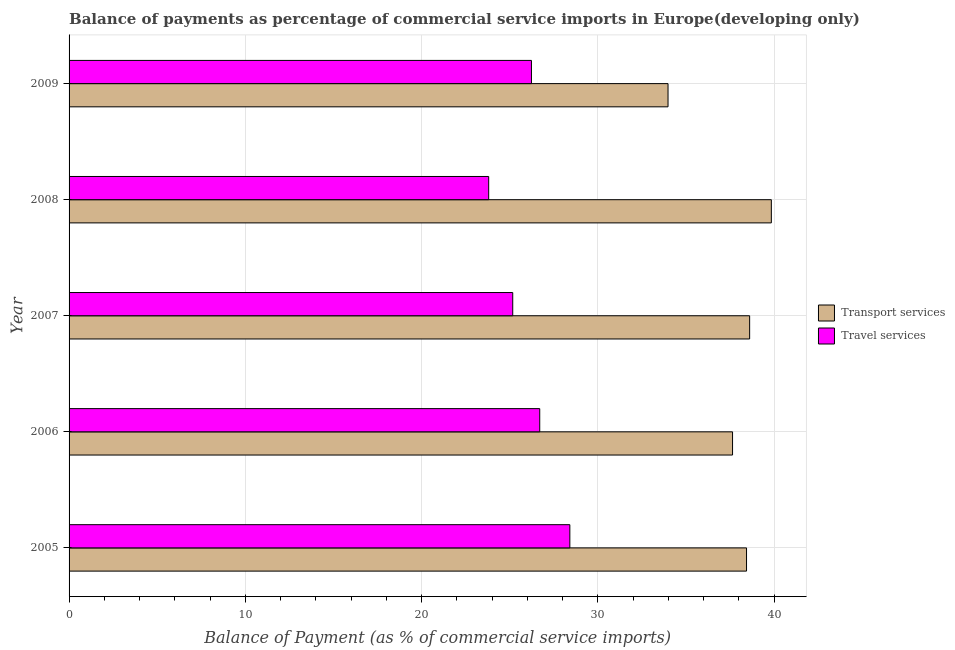What is the label of the 5th group of bars from the top?
Make the answer very short. 2005. What is the balance of payments of travel services in 2008?
Provide a succinct answer. 23.81. Across all years, what is the maximum balance of payments of travel services?
Provide a short and direct response. 28.42. Across all years, what is the minimum balance of payments of transport services?
Provide a succinct answer. 33.99. In which year was the balance of payments of travel services minimum?
Keep it short and to the point. 2008. What is the total balance of payments of transport services in the graph?
Your response must be concise. 188.54. What is the difference between the balance of payments of travel services in 2006 and that in 2007?
Your response must be concise. 1.53. What is the difference between the balance of payments of travel services in 2008 and the balance of payments of transport services in 2007?
Offer a terse response. -14.81. What is the average balance of payments of travel services per year?
Your answer should be compact. 26.07. In the year 2006, what is the difference between the balance of payments of travel services and balance of payments of transport services?
Keep it short and to the point. -10.94. In how many years, is the balance of payments of transport services greater than 2 %?
Keep it short and to the point. 5. What is the ratio of the balance of payments of travel services in 2006 to that in 2007?
Your answer should be very brief. 1.06. Is the balance of payments of travel services in 2006 less than that in 2009?
Ensure brevity in your answer.  No. What is the difference between the highest and the second highest balance of payments of travel services?
Your answer should be compact. 1.71. What is the difference between the highest and the lowest balance of payments of transport services?
Give a very brief answer. 5.86. Is the sum of the balance of payments of transport services in 2008 and 2009 greater than the maximum balance of payments of travel services across all years?
Make the answer very short. Yes. What does the 2nd bar from the top in 2007 represents?
Provide a short and direct response. Transport services. What does the 2nd bar from the bottom in 2009 represents?
Keep it short and to the point. Travel services. How many bars are there?
Offer a terse response. 10. What is the difference between two consecutive major ticks on the X-axis?
Your answer should be compact. 10. How many legend labels are there?
Make the answer very short. 2. How are the legend labels stacked?
Provide a succinct answer. Vertical. What is the title of the graph?
Your response must be concise. Balance of payments as percentage of commercial service imports in Europe(developing only). What is the label or title of the X-axis?
Provide a succinct answer. Balance of Payment (as % of commercial service imports). What is the Balance of Payment (as % of commercial service imports) of Transport services in 2005?
Keep it short and to the point. 38.44. What is the Balance of Payment (as % of commercial service imports) of Travel services in 2005?
Ensure brevity in your answer.  28.42. What is the Balance of Payment (as % of commercial service imports) in Transport services in 2006?
Make the answer very short. 37.65. What is the Balance of Payment (as % of commercial service imports) of Travel services in 2006?
Provide a succinct answer. 26.71. What is the Balance of Payment (as % of commercial service imports) of Transport services in 2007?
Offer a very short reply. 38.62. What is the Balance of Payment (as % of commercial service imports) of Travel services in 2007?
Keep it short and to the point. 25.17. What is the Balance of Payment (as % of commercial service imports) in Transport services in 2008?
Offer a very short reply. 39.85. What is the Balance of Payment (as % of commercial service imports) in Travel services in 2008?
Your answer should be very brief. 23.81. What is the Balance of Payment (as % of commercial service imports) in Transport services in 2009?
Provide a succinct answer. 33.99. What is the Balance of Payment (as % of commercial service imports) in Travel services in 2009?
Provide a succinct answer. 26.24. Across all years, what is the maximum Balance of Payment (as % of commercial service imports) of Transport services?
Your answer should be compact. 39.85. Across all years, what is the maximum Balance of Payment (as % of commercial service imports) in Travel services?
Provide a short and direct response. 28.42. Across all years, what is the minimum Balance of Payment (as % of commercial service imports) of Transport services?
Your answer should be compact. 33.99. Across all years, what is the minimum Balance of Payment (as % of commercial service imports) in Travel services?
Ensure brevity in your answer.  23.81. What is the total Balance of Payment (as % of commercial service imports) in Transport services in the graph?
Offer a terse response. 188.54. What is the total Balance of Payment (as % of commercial service imports) in Travel services in the graph?
Your answer should be very brief. 130.34. What is the difference between the Balance of Payment (as % of commercial service imports) of Transport services in 2005 and that in 2006?
Keep it short and to the point. 0.79. What is the difference between the Balance of Payment (as % of commercial service imports) in Travel services in 2005 and that in 2006?
Provide a succinct answer. 1.71. What is the difference between the Balance of Payment (as % of commercial service imports) of Transport services in 2005 and that in 2007?
Make the answer very short. -0.18. What is the difference between the Balance of Payment (as % of commercial service imports) in Travel services in 2005 and that in 2007?
Give a very brief answer. 3.24. What is the difference between the Balance of Payment (as % of commercial service imports) of Transport services in 2005 and that in 2008?
Provide a succinct answer. -1.41. What is the difference between the Balance of Payment (as % of commercial service imports) of Travel services in 2005 and that in 2008?
Offer a very short reply. 4.61. What is the difference between the Balance of Payment (as % of commercial service imports) in Transport services in 2005 and that in 2009?
Your answer should be very brief. 4.45. What is the difference between the Balance of Payment (as % of commercial service imports) in Travel services in 2005 and that in 2009?
Your answer should be very brief. 2.18. What is the difference between the Balance of Payment (as % of commercial service imports) of Transport services in 2006 and that in 2007?
Your answer should be compact. -0.97. What is the difference between the Balance of Payment (as % of commercial service imports) of Travel services in 2006 and that in 2007?
Ensure brevity in your answer.  1.53. What is the difference between the Balance of Payment (as % of commercial service imports) of Transport services in 2006 and that in 2008?
Offer a terse response. -2.2. What is the difference between the Balance of Payment (as % of commercial service imports) of Travel services in 2006 and that in 2008?
Offer a terse response. 2.9. What is the difference between the Balance of Payment (as % of commercial service imports) of Transport services in 2006 and that in 2009?
Give a very brief answer. 3.66. What is the difference between the Balance of Payment (as % of commercial service imports) of Travel services in 2006 and that in 2009?
Provide a short and direct response. 0.47. What is the difference between the Balance of Payment (as % of commercial service imports) in Transport services in 2007 and that in 2008?
Make the answer very short. -1.23. What is the difference between the Balance of Payment (as % of commercial service imports) of Travel services in 2007 and that in 2008?
Your response must be concise. 1.36. What is the difference between the Balance of Payment (as % of commercial service imports) of Transport services in 2007 and that in 2009?
Your answer should be very brief. 4.63. What is the difference between the Balance of Payment (as % of commercial service imports) in Travel services in 2007 and that in 2009?
Your answer should be very brief. -1.06. What is the difference between the Balance of Payment (as % of commercial service imports) in Transport services in 2008 and that in 2009?
Your response must be concise. 5.86. What is the difference between the Balance of Payment (as % of commercial service imports) of Travel services in 2008 and that in 2009?
Give a very brief answer. -2.43. What is the difference between the Balance of Payment (as % of commercial service imports) in Transport services in 2005 and the Balance of Payment (as % of commercial service imports) in Travel services in 2006?
Provide a succinct answer. 11.73. What is the difference between the Balance of Payment (as % of commercial service imports) of Transport services in 2005 and the Balance of Payment (as % of commercial service imports) of Travel services in 2007?
Give a very brief answer. 13.27. What is the difference between the Balance of Payment (as % of commercial service imports) in Transport services in 2005 and the Balance of Payment (as % of commercial service imports) in Travel services in 2008?
Offer a very short reply. 14.63. What is the difference between the Balance of Payment (as % of commercial service imports) in Transport services in 2005 and the Balance of Payment (as % of commercial service imports) in Travel services in 2009?
Your answer should be very brief. 12.2. What is the difference between the Balance of Payment (as % of commercial service imports) of Transport services in 2006 and the Balance of Payment (as % of commercial service imports) of Travel services in 2007?
Offer a terse response. 12.47. What is the difference between the Balance of Payment (as % of commercial service imports) in Transport services in 2006 and the Balance of Payment (as % of commercial service imports) in Travel services in 2008?
Make the answer very short. 13.84. What is the difference between the Balance of Payment (as % of commercial service imports) of Transport services in 2006 and the Balance of Payment (as % of commercial service imports) of Travel services in 2009?
Your answer should be compact. 11.41. What is the difference between the Balance of Payment (as % of commercial service imports) in Transport services in 2007 and the Balance of Payment (as % of commercial service imports) in Travel services in 2008?
Make the answer very short. 14.81. What is the difference between the Balance of Payment (as % of commercial service imports) of Transport services in 2007 and the Balance of Payment (as % of commercial service imports) of Travel services in 2009?
Provide a succinct answer. 12.38. What is the difference between the Balance of Payment (as % of commercial service imports) in Transport services in 2008 and the Balance of Payment (as % of commercial service imports) in Travel services in 2009?
Provide a succinct answer. 13.61. What is the average Balance of Payment (as % of commercial service imports) in Transport services per year?
Provide a succinct answer. 37.71. What is the average Balance of Payment (as % of commercial service imports) of Travel services per year?
Offer a very short reply. 26.07. In the year 2005, what is the difference between the Balance of Payment (as % of commercial service imports) of Transport services and Balance of Payment (as % of commercial service imports) of Travel services?
Your answer should be very brief. 10.03. In the year 2006, what is the difference between the Balance of Payment (as % of commercial service imports) of Transport services and Balance of Payment (as % of commercial service imports) of Travel services?
Provide a short and direct response. 10.94. In the year 2007, what is the difference between the Balance of Payment (as % of commercial service imports) in Transport services and Balance of Payment (as % of commercial service imports) in Travel services?
Provide a short and direct response. 13.44. In the year 2008, what is the difference between the Balance of Payment (as % of commercial service imports) of Transport services and Balance of Payment (as % of commercial service imports) of Travel services?
Provide a succinct answer. 16.04. In the year 2009, what is the difference between the Balance of Payment (as % of commercial service imports) of Transport services and Balance of Payment (as % of commercial service imports) of Travel services?
Give a very brief answer. 7.75. What is the ratio of the Balance of Payment (as % of commercial service imports) of Transport services in 2005 to that in 2006?
Make the answer very short. 1.02. What is the ratio of the Balance of Payment (as % of commercial service imports) in Travel services in 2005 to that in 2006?
Keep it short and to the point. 1.06. What is the ratio of the Balance of Payment (as % of commercial service imports) of Transport services in 2005 to that in 2007?
Provide a succinct answer. 1. What is the ratio of the Balance of Payment (as % of commercial service imports) of Travel services in 2005 to that in 2007?
Offer a terse response. 1.13. What is the ratio of the Balance of Payment (as % of commercial service imports) in Transport services in 2005 to that in 2008?
Your answer should be very brief. 0.96. What is the ratio of the Balance of Payment (as % of commercial service imports) in Travel services in 2005 to that in 2008?
Ensure brevity in your answer.  1.19. What is the ratio of the Balance of Payment (as % of commercial service imports) in Transport services in 2005 to that in 2009?
Your answer should be compact. 1.13. What is the ratio of the Balance of Payment (as % of commercial service imports) in Travel services in 2005 to that in 2009?
Your response must be concise. 1.08. What is the ratio of the Balance of Payment (as % of commercial service imports) in Transport services in 2006 to that in 2007?
Make the answer very short. 0.97. What is the ratio of the Balance of Payment (as % of commercial service imports) in Travel services in 2006 to that in 2007?
Keep it short and to the point. 1.06. What is the ratio of the Balance of Payment (as % of commercial service imports) in Transport services in 2006 to that in 2008?
Your answer should be very brief. 0.94. What is the ratio of the Balance of Payment (as % of commercial service imports) in Travel services in 2006 to that in 2008?
Your answer should be very brief. 1.12. What is the ratio of the Balance of Payment (as % of commercial service imports) of Transport services in 2006 to that in 2009?
Offer a terse response. 1.11. What is the ratio of the Balance of Payment (as % of commercial service imports) of Travel services in 2006 to that in 2009?
Offer a very short reply. 1.02. What is the ratio of the Balance of Payment (as % of commercial service imports) of Transport services in 2007 to that in 2008?
Your answer should be very brief. 0.97. What is the ratio of the Balance of Payment (as % of commercial service imports) of Travel services in 2007 to that in 2008?
Your answer should be compact. 1.06. What is the ratio of the Balance of Payment (as % of commercial service imports) in Transport services in 2007 to that in 2009?
Offer a very short reply. 1.14. What is the ratio of the Balance of Payment (as % of commercial service imports) in Travel services in 2007 to that in 2009?
Provide a short and direct response. 0.96. What is the ratio of the Balance of Payment (as % of commercial service imports) of Transport services in 2008 to that in 2009?
Offer a terse response. 1.17. What is the ratio of the Balance of Payment (as % of commercial service imports) of Travel services in 2008 to that in 2009?
Make the answer very short. 0.91. What is the difference between the highest and the second highest Balance of Payment (as % of commercial service imports) of Transport services?
Your response must be concise. 1.23. What is the difference between the highest and the second highest Balance of Payment (as % of commercial service imports) of Travel services?
Provide a succinct answer. 1.71. What is the difference between the highest and the lowest Balance of Payment (as % of commercial service imports) of Transport services?
Provide a short and direct response. 5.86. What is the difference between the highest and the lowest Balance of Payment (as % of commercial service imports) of Travel services?
Offer a terse response. 4.61. 